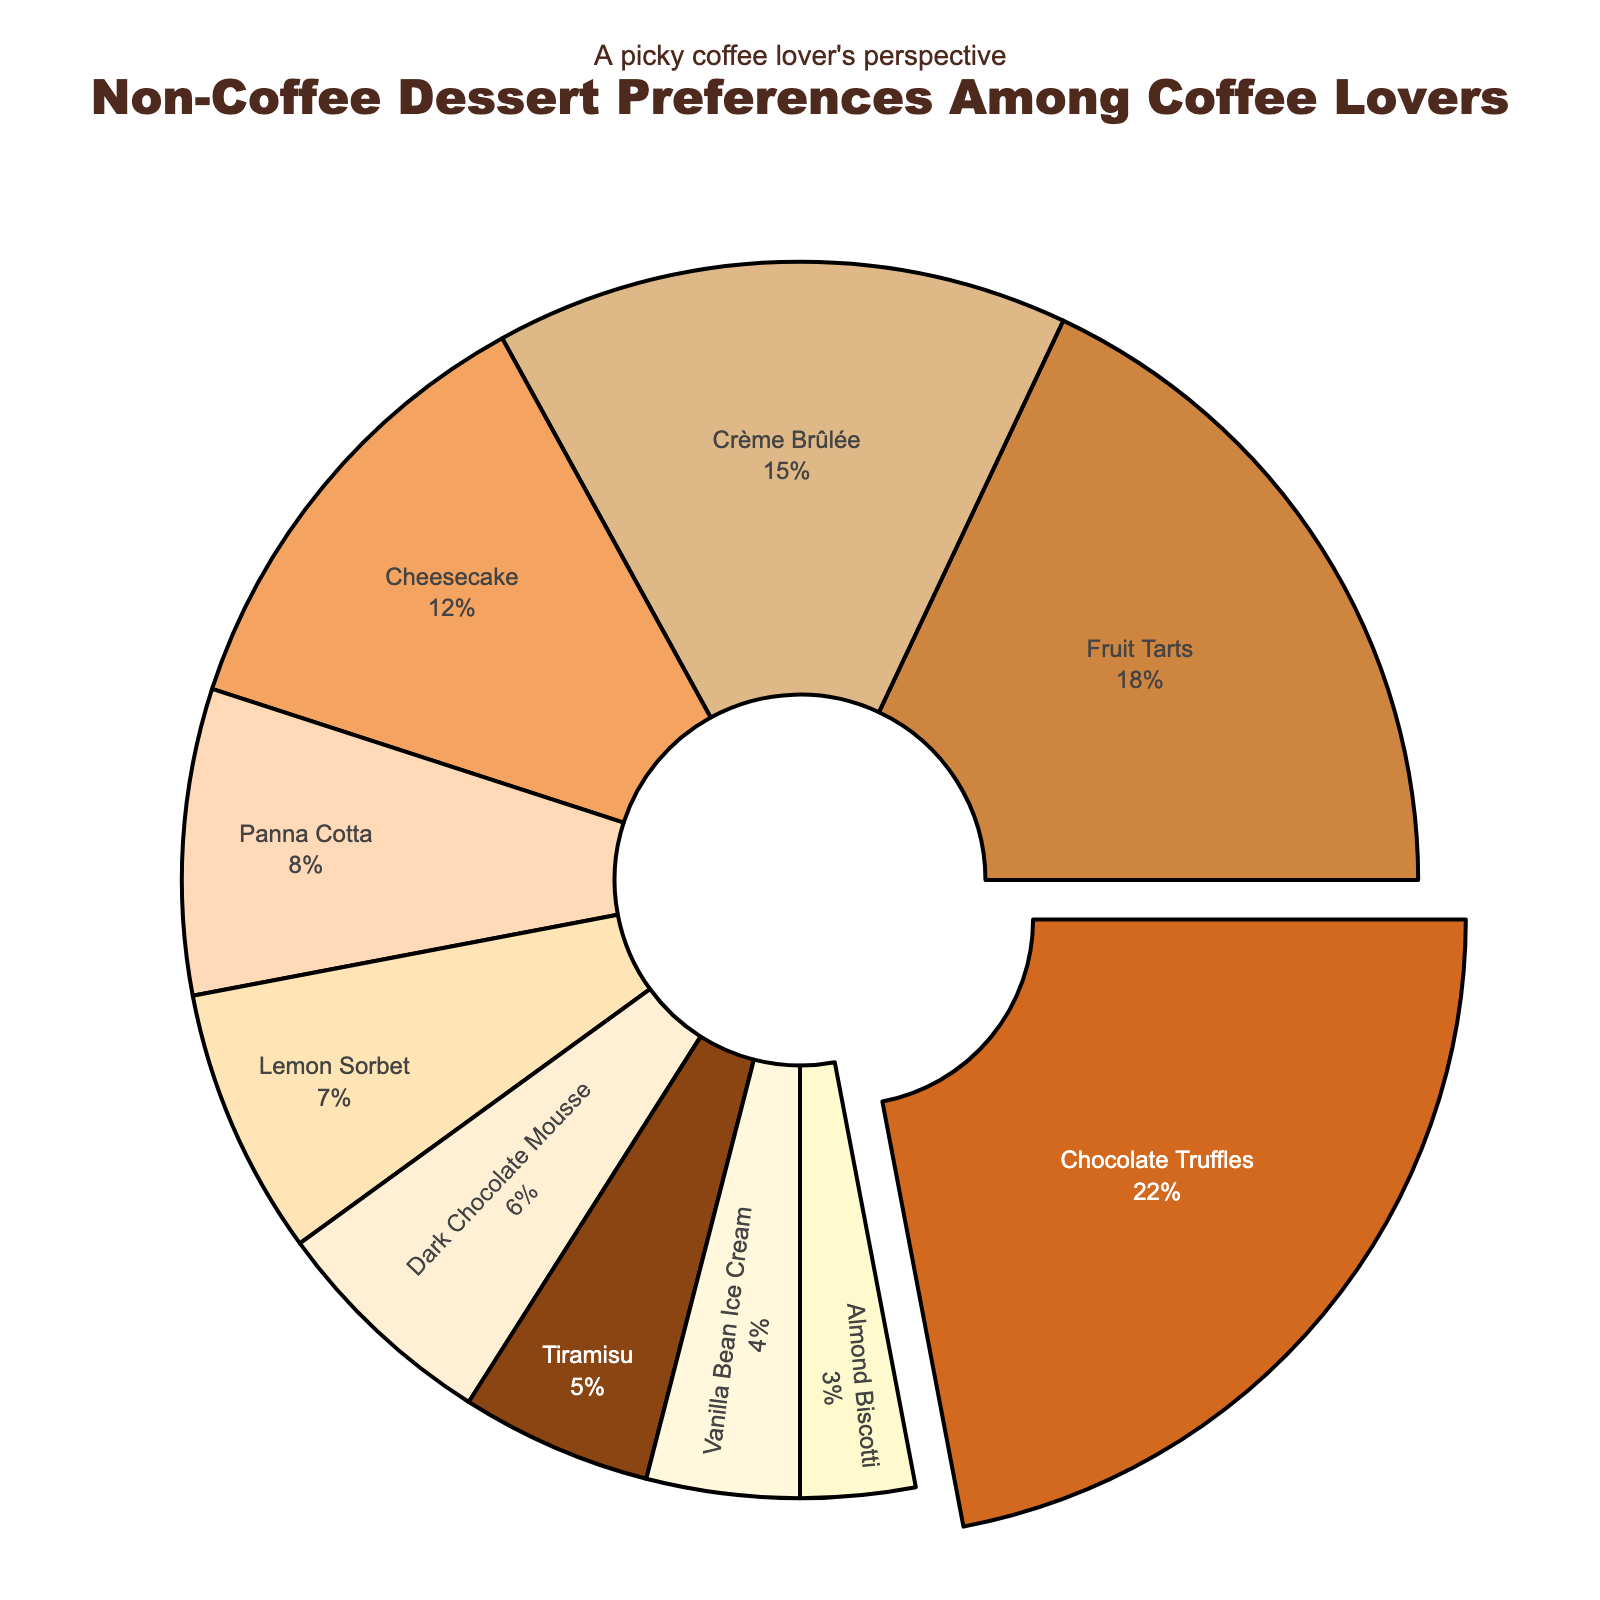Which non-coffee dessert is the most popular among coffee lovers? The most popular dessert will be the one with the highest percentage. By analyzing the figure, Chocolate Truffles has the largest segment.
Answer: Chocolate Truffles Which non-coffee dessert has the smallest segment in the pie chart? The smallest segment represents the dessert with the lowest percentage. Almond Biscotti, with only 3%, is the smallest segment.
Answer: Almond Biscotti How much more popular are Chocolate Truffles than Tiramisu? First, find the percentage for Chocolate Truffles (22%) and Tiramisu (5%). Then, subtract the percentage for Tiramisu from Chocolate Truffles: 22% - 5% = 17%.
Answer: 17% What is the combined percentage of Crème Brûlée, Cheesecake, and Panna Cotta? Add the percentages of Crème Brûlée (15%), Cheesecake (12%), and Panna Cotta (8%): 15% + 12% + 8% = 35%.
Answer: 35% Is Lemon Sorbet more popular than Panna Cotta? Compare the percentages: Lemon Sorbet is 7% and Panna Cotta is 8%. Lemon Sorbet is not more popular.
Answer: No Which dessert accounts for a larger share, Fruit Tarts or Dark Chocolate Mousse? Compare the percentages: Fruit Tarts have 18% and Dark Chocolate Mousse has 6%. Fruit Tarts account for a larger share.
Answer: Fruit Tarts By how much does the percentage of Cheesecake exceed that of Vanilla Bean Ice Cream? Find the percentage for Cheesecake (12%) and Vanilla Bean Ice Cream (4%). Then, subtract Vanilla Bean Ice Cream’s percentage from Cheesecake’s: 12% - 4% = 8%.
Answer: 8% What is the difference in popularity between the least popular and the most popular non-coffee desserts? The least popular dessert is Almond Biscotti (3%) and the most popular is Chocolate Truffles (22%). Subtract the smallest percentage from the largest: 22% - 3% = 19%.
Answer: 19% What is the average percentage of Dark Chocolate Mousse, Vanilla Bean Ice Cream, and Almond Biscotti? Add the percentages and divide by the number of segments: (6% + 4% + 3%) / 3 = 13% / 3 = 4.33%.
Answer: 4.33% If the combined percentage of Fruit Tarts and Lemon Sorbet were increased by 5%, what would that new value be? Find the current combined percentage of Fruit Tarts (18%) and Lemon Sorbet (7%): 18% + 7% = 25%. Add the 5% increase: 25% + 5% = 30%.
Answer: 30% 